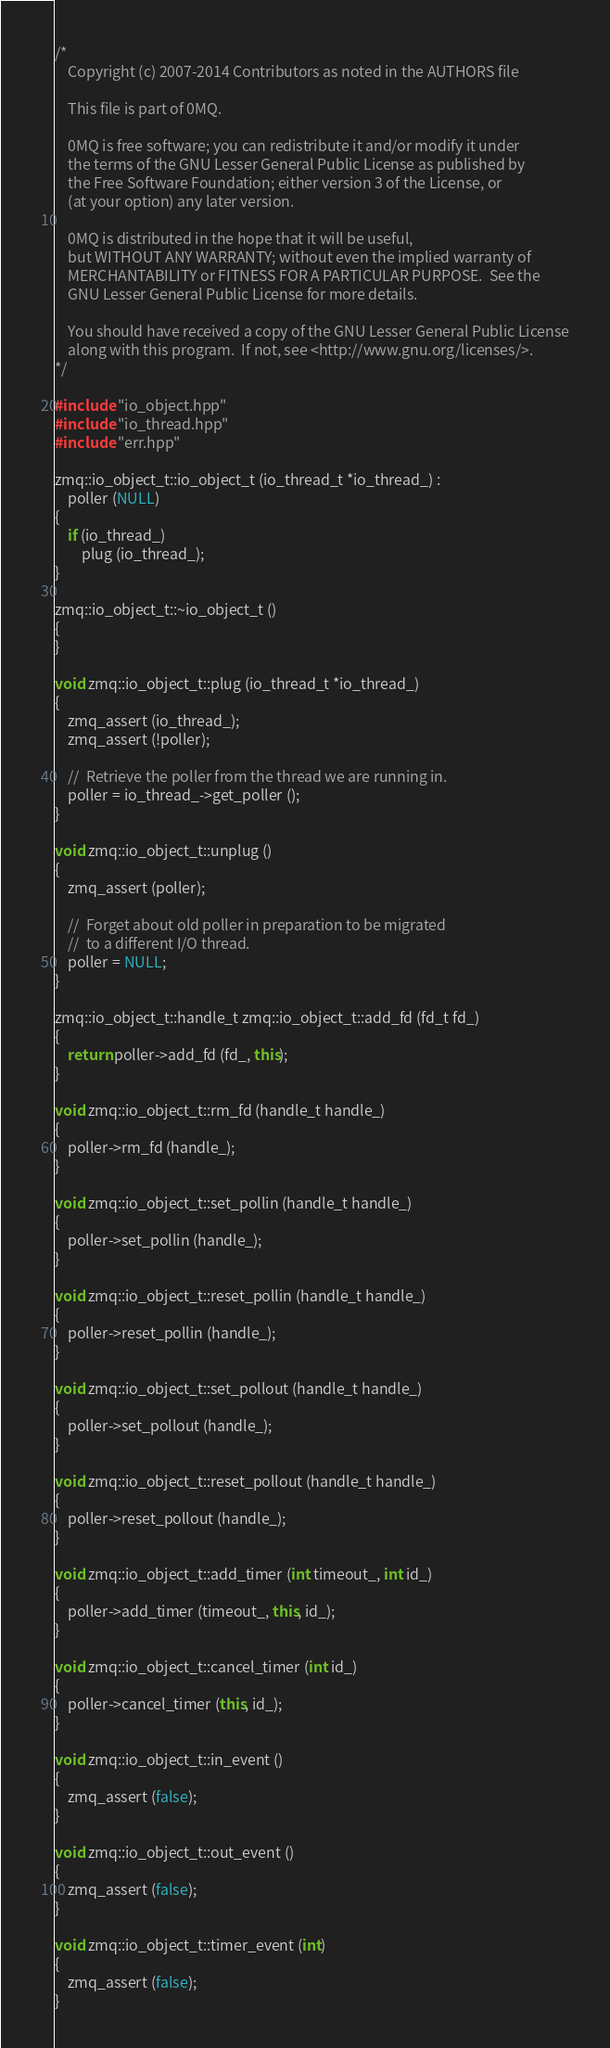Convert code to text. <code><loc_0><loc_0><loc_500><loc_500><_C++_>/*
    Copyright (c) 2007-2014 Contributors as noted in the AUTHORS file

    This file is part of 0MQ.

    0MQ is free software; you can redistribute it and/or modify it under
    the terms of the GNU Lesser General Public License as published by
    the Free Software Foundation; either version 3 of the License, or
    (at your option) any later version.

    0MQ is distributed in the hope that it will be useful,
    but WITHOUT ANY WARRANTY; without even the implied warranty of
    MERCHANTABILITY or FITNESS FOR A PARTICULAR PURPOSE.  See the
    GNU Lesser General Public License for more details.

    You should have received a copy of the GNU Lesser General Public License
    along with this program.  If not, see <http://www.gnu.org/licenses/>.
*/

#include "io_object.hpp"
#include "io_thread.hpp"
#include "err.hpp"

zmq::io_object_t::io_object_t (io_thread_t *io_thread_) :
    poller (NULL)
{
    if (io_thread_)
        plug (io_thread_);
}

zmq::io_object_t::~io_object_t ()
{
}

void zmq::io_object_t::plug (io_thread_t *io_thread_)
{
    zmq_assert (io_thread_);
    zmq_assert (!poller);

    //  Retrieve the poller from the thread we are running in.
    poller = io_thread_->get_poller ();
}

void zmq::io_object_t::unplug ()
{
    zmq_assert (poller);

    //  Forget about old poller in preparation to be migrated
    //  to a different I/O thread.
    poller = NULL;
}

zmq::io_object_t::handle_t zmq::io_object_t::add_fd (fd_t fd_)
{
    return poller->add_fd (fd_, this);
}

void zmq::io_object_t::rm_fd (handle_t handle_)
{
    poller->rm_fd (handle_);
}

void zmq::io_object_t::set_pollin (handle_t handle_)
{
    poller->set_pollin (handle_);
}

void zmq::io_object_t::reset_pollin (handle_t handle_)
{
    poller->reset_pollin (handle_);
}

void zmq::io_object_t::set_pollout (handle_t handle_)
{
    poller->set_pollout (handle_);
}

void zmq::io_object_t::reset_pollout (handle_t handle_)
{
    poller->reset_pollout (handle_);
}

void zmq::io_object_t::add_timer (int timeout_, int id_)
{
    poller->add_timer (timeout_, this, id_);
}

void zmq::io_object_t::cancel_timer (int id_)
{
    poller->cancel_timer (this, id_);
}

void zmq::io_object_t::in_event ()
{
    zmq_assert (false);
}

void zmq::io_object_t::out_event ()
{
    zmq_assert (false);
}

void zmq::io_object_t::timer_event (int)
{
    zmq_assert (false);
}
</code> 